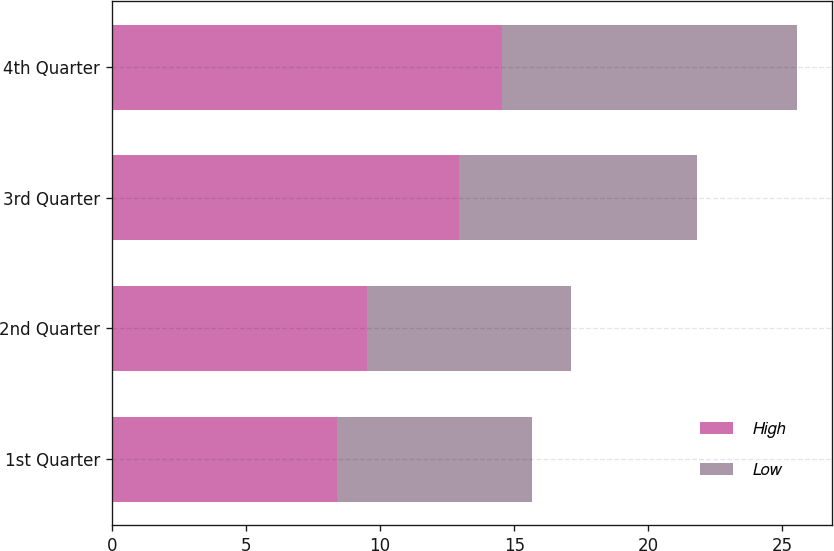Convert chart. <chart><loc_0><loc_0><loc_500><loc_500><stacked_bar_chart><ecel><fcel>1st Quarter<fcel>2nd Quarter<fcel>3rd Quarter<fcel>4th Quarter<nl><fcel>High<fcel>8.4<fcel>9.52<fcel>12.95<fcel>14.54<nl><fcel>Low<fcel>7.25<fcel>7.6<fcel>8.85<fcel>11.02<nl></chart> 